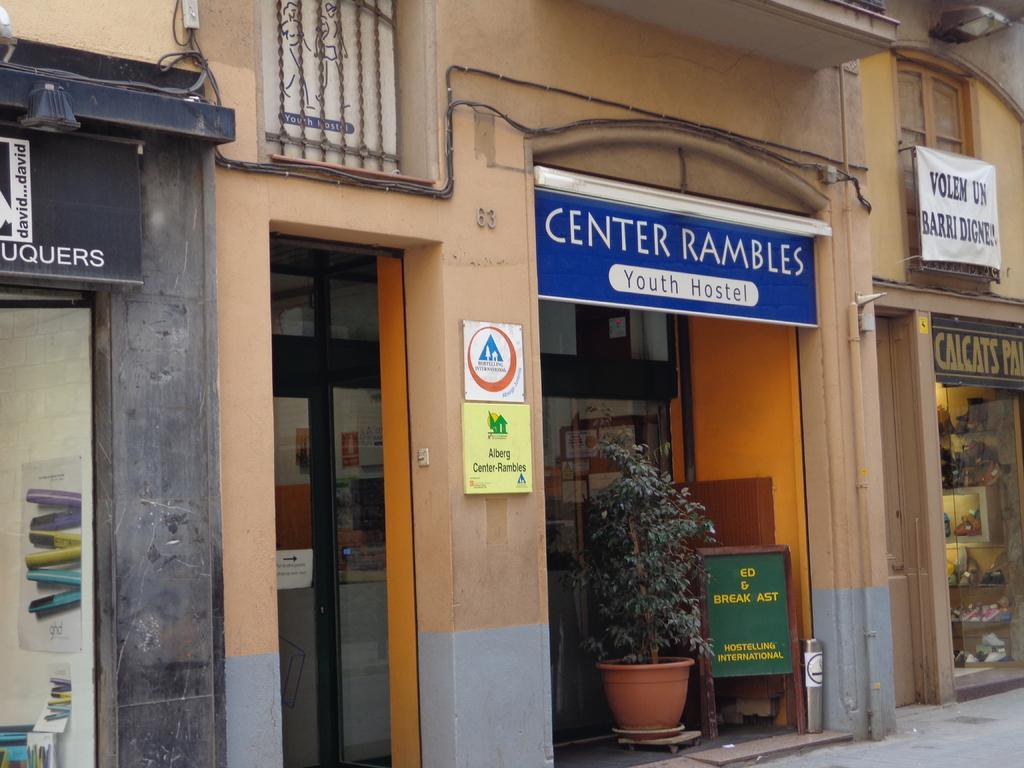Please provide a concise description of this image. Here we can see a building and there is a name board on it and we can see small boards on the wall,hoardings,pipes,cables on the wall,house plant in a pot,posters on the wall,glass doors and through the glass door we can see objects. 